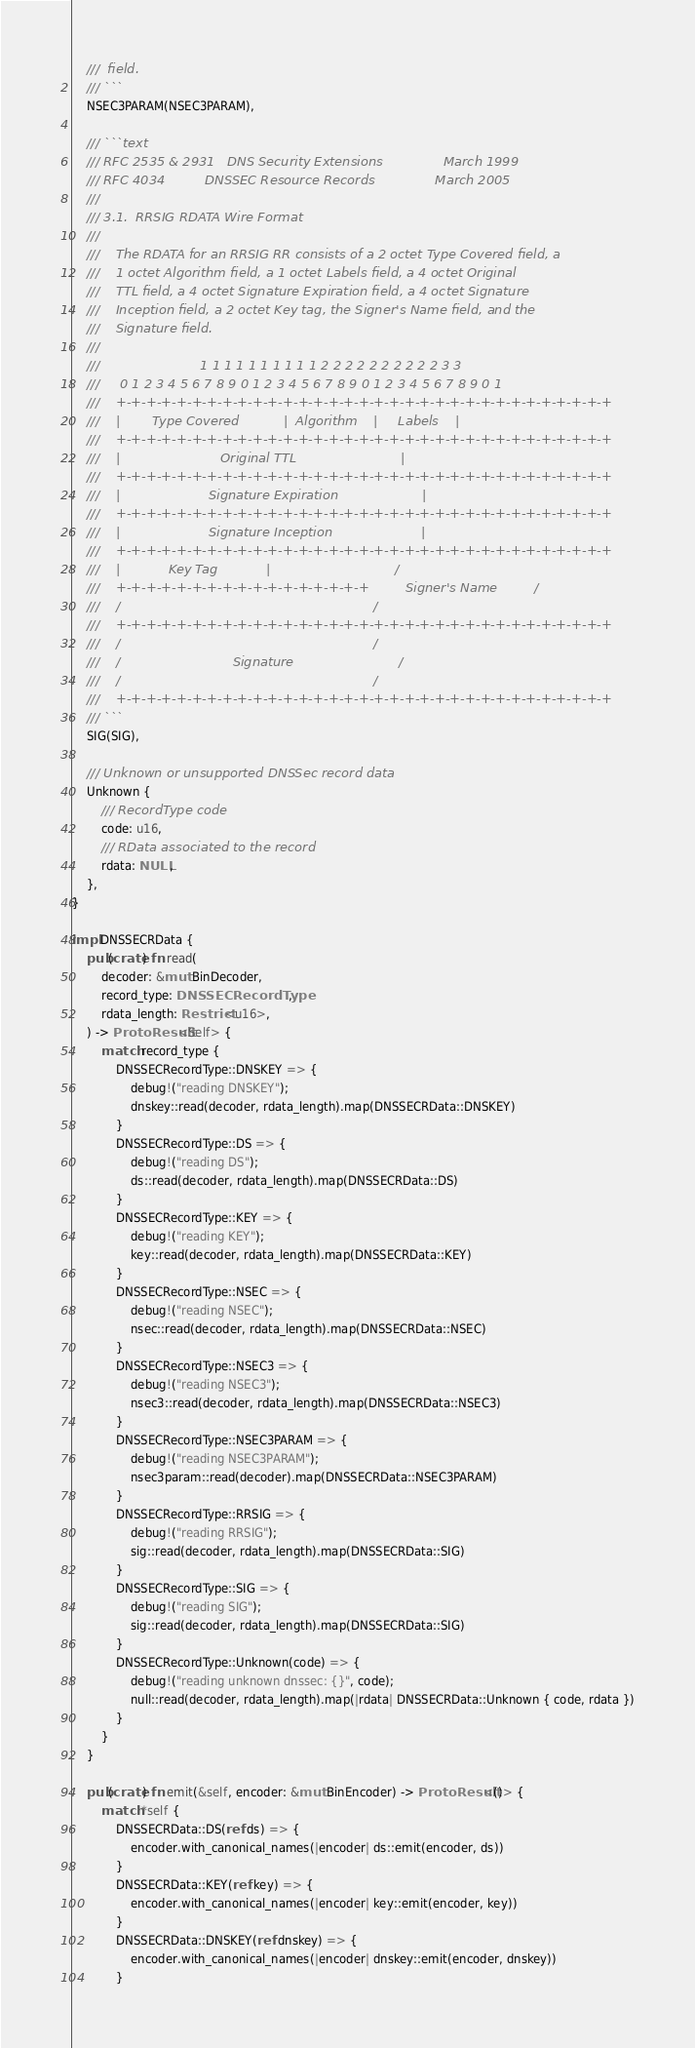Convert code to text. <code><loc_0><loc_0><loc_500><loc_500><_Rust_>    ///  field.
    /// ```
    NSEC3PARAM(NSEC3PARAM),

    /// ```text
    /// RFC 2535 & 2931   DNS Security Extensions               March 1999
    /// RFC 4034          DNSSEC Resource Records               March 2005
    ///
    /// 3.1.  RRSIG RDATA Wire Format
    ///
    ///    The RDATA for an RRSIG RR consists of a 2 octet Type Covered field, a
    ///    1 octet Algorithm field, a 1 octet Labels field, a 4 octet Original
    ///    TTL field, a 4 octet Signature Expiration field, a 4 octet Signature
    ///    Inception field, a 2 octet Key tag, the Signer's Name field, and the
    ///    Signature field.
    ///
    ///                         1 1 1 1 1 1 1 1 1 1 2 2 2 2 2 2 2 2 2 2 3 3
    ///     0 1 2 3 4 5 6 7 8 9 0 1 2 3 4 5 6 7 8 9 0 1 2 3 4 5 6 7 8 9 0 1
    ///    +-+-+-+-+-+-+-+-+-+-+-+-+-+-+-+-+-+-+-+-+-+-+-+-+-+-+-+-+-+-+-+-+
    ///    |        Type Covered           |  Algorithm    |     Labels    |
    ///    +-+-+-+-+-+-+-+-+-+-+-+-+-+-+-+-+-+-+-+-+-+-+-+-+-+-+-+-+-+-+-+-+
    ///    |                         Original TTL                          |
    ///    +-+-+-+-+-+-+-+-+-+-+-+-+-+-+-+-+-+-+-+-+-+-+-+-+-+-+-+-+-+-+-+-+
    ///    |                      Signature Expiration                     |
    ///    +-+-+-+-+-+-+-+-+-+-+-+-+-+-+-+-+-+-+-+-+-+-+-+-+-+-+-+-+-+-+-+-+
    ///    |                      Signature Inception                      |
    ///    +-+-+-+-+-+-+-+-+-+-+-+-+-+-+-+-+-+-+-+-+-+-+-+-+-+-+-+-+-+-+-+-+
    ///    |            Key Tag            |                               /
    ///    +-+-+-+-+-+-+-+-+-+-+-+-+-+-+-+-+         Signer's Name         /
    ///    /                                                               /
    ///    +-+-+-+-+-+-+-+-+-+-+-+-+-+-+-+-+-+-+-+-+-+-+-+-+-+-+-+-+-+-+-+-+
    ///    /                                                               /
    ///    /                            Signature                          /
    ///    /                                                               /
    ///    +-+-+-+-+-+-+-+-+-+-+-+-+-+-+-+-+-+-+-+-+-+-+-+-+-+-+-+-+-+-+-+-+
    /// ```
    SIG(SIG),

    /// Unknown or unsupported DNSSec record data
    Unknown {
        /// RecordType code
        code: u16,
        /// RData associated to the record
        rdata: NULL,
    },
}

impl DNSSECRData {
    pub(crate) fn read(
        decoder: &mut BinDecoder,
        record_type: DNSSECRecordType,
        rdata_length: Restrict<u16>,
    ) -> ProtoResult<Self> {
        match record_type {
            DNSSECRecordType::DNSKEY => {
                debug!("reading DNSKEY");
                dnskey::read(decoder, rdata_length).map(DNSSECRData::DNSKEY)
            }
            DNSSECRecordType::DS => {
                debug!("reading DS");
                ds::read(decoder, rdata_length).map(DNSSECRData::DS)
            }
            DNSSECRecordType::KEY => {
                debug!("reading KEY");
                key::read(decoder, rdata_length).map(DNSSECRData::KEY)
            }
            DNSSECRecordType::NSEC => {
                debug!("reading NSEC");
                nsec::read(decoder, rdata_length).map(DNSSECRData::NSEC)
            }
            DNSSECRecordType::NSEC3 => {
                debug!("reading NSEC3");
                nsec3::read(decoder, rdata_length).map(DNSSECRData::NSEC3)
            }
            DNSSECRecordType::NSEC3PARAM => {
                debug!("reading NSEC3PARAM");
                nsec3param::read(decoder).map(DNSSECRData::NSEC3PARAM)
            }
            DNSSECRecordType::RRSIG => {
                debug!("reading RRSIG");
                sig::read(decoder, rdata_length).map(DNSSECRData::SIG)
            }
            DNSSECRecordType::SIG => {
                debug!("reading SIG");
                sig::read(decoder, rdata_length).map(DNSSECRData::SIG)
            }
            DNSSECRecordType::Unknown(code) => {
                debug!("reading unknown dnssec: {}", code);
                null::read(decoder, rdata_length).map(|rdata| DNSSECRData::Unknown { code, rdata })
            }
        }
    }

    pub(crate) fn emit(&self, encoder: &mut BinEncoder) -> ProtoResult<()> {
        match *self {
            DNSSECRData::DS(ref ds) => {
                encoder.with_canonical_names(|encoder| ds::emit(encoder, ds))
            }
            DNSSECRData::KEY(ref key) => {
                encoder.with_canonical_names(|encoder| key::emit(encoder, key))
            }
            DNSSECRData::DNSKEY(ref dnskey) => {
                encoder.with_canonical_names(|encoder| dnskey::emit(encoder, dnskey))
            }</code> 